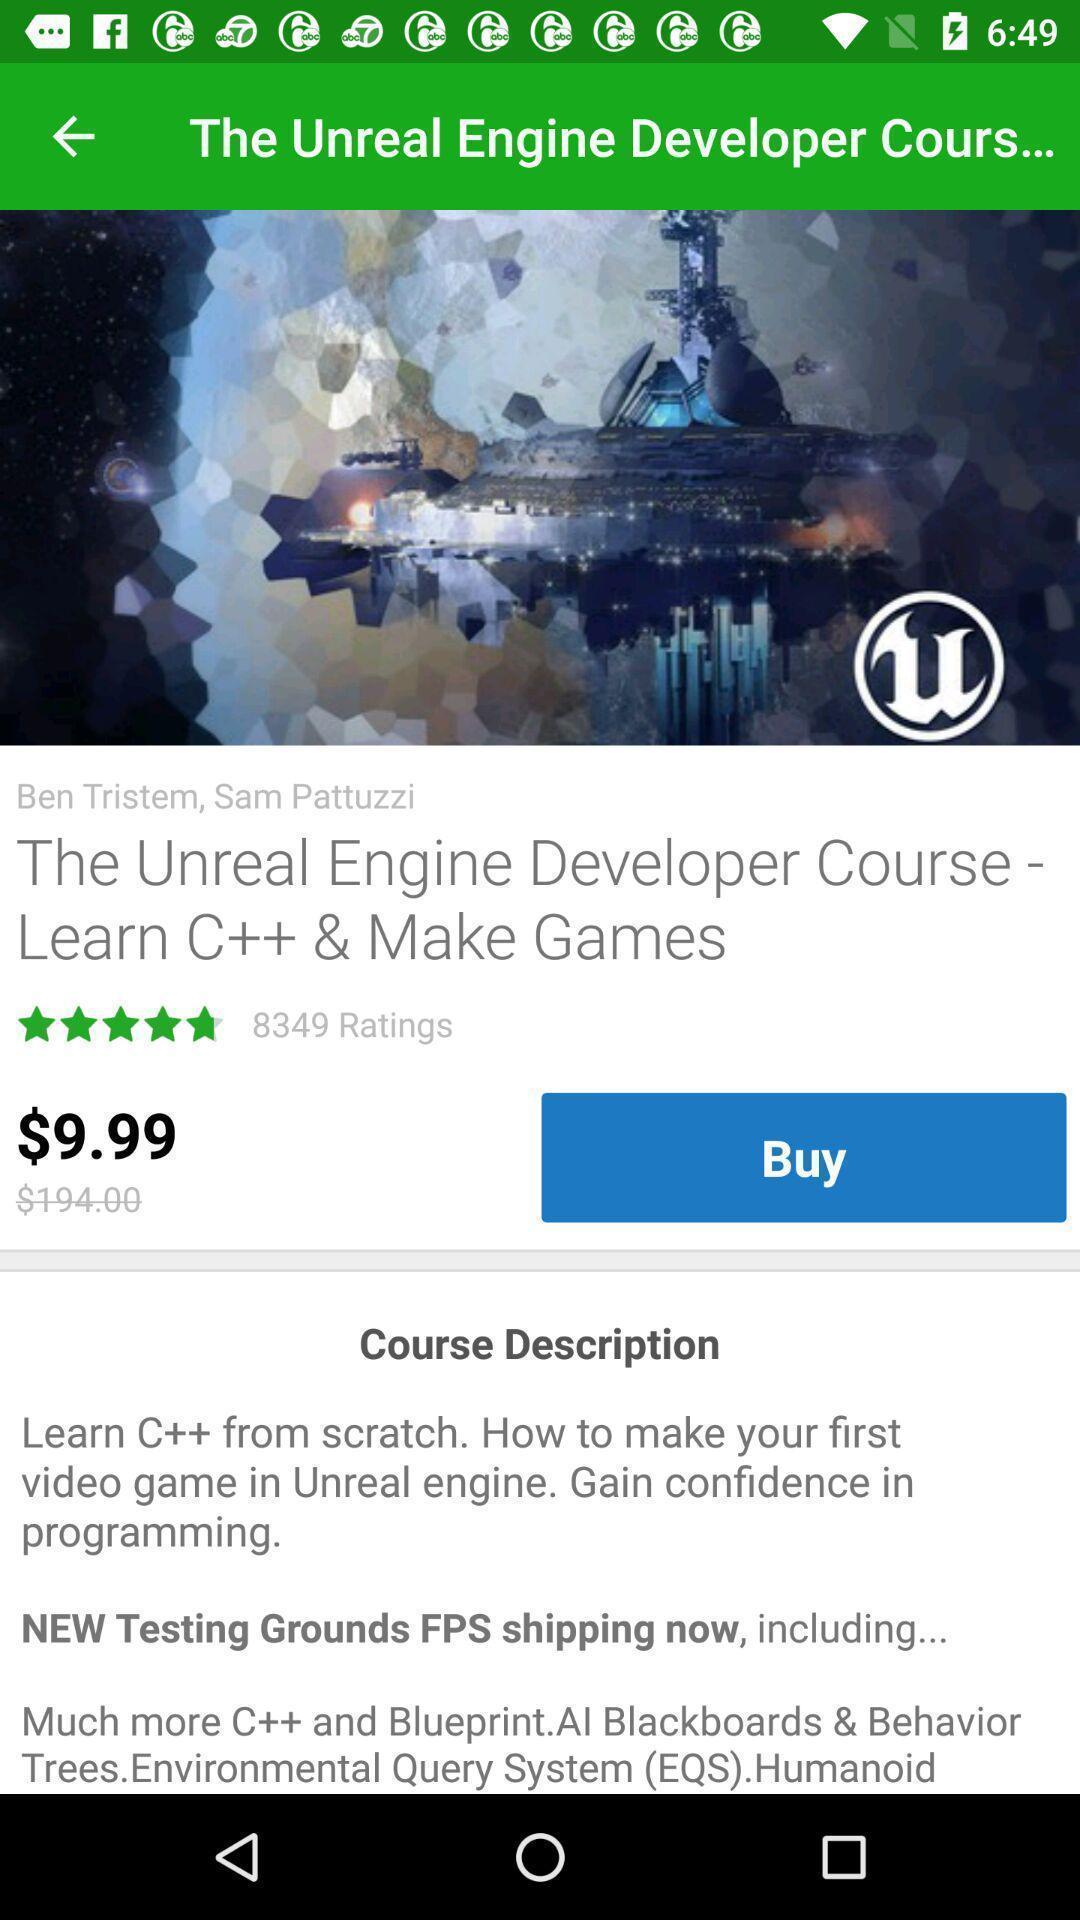Provide a textual representation of this image. Page showing course with description in a learning app. 